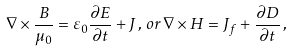Convert formula to latex. <formula><loc_0><loc_0><loc_500><loc_500>\nabla \times \frac { B } { \mu _ { 0 } } = \varepsilon _ { 0 } \frac { \partial E } { \partial t } + J \, , \, o r \, \nabla \times { H } = J _ { f } + \frac { \partial D } { \partial t } \, ,</formula> 